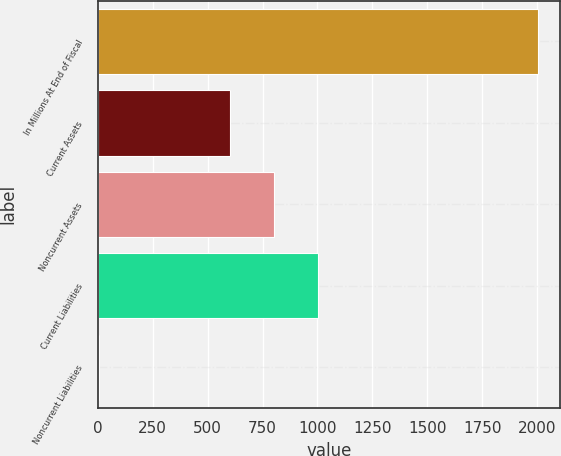<chart> <loc_0><loc_0><loc_500><loc_500><bar_chart><fcel>In Millions At End of Fiscal<fcel>Current Assets<fcel>Noncurrent Assets<fcel>Current Liabilities<fcel>Noncurrent Liabilities<nl><fcel>2005<fcel>604<fcel>803.8<fcel>1003.6<fcel>7<nl></chart> 